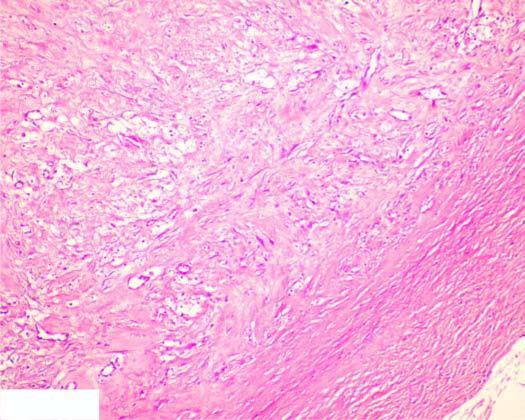s the circumscribed lesion composed of mature collagenised fibrous connective tissue?
Answer the question using a single word or phrase. Yes 